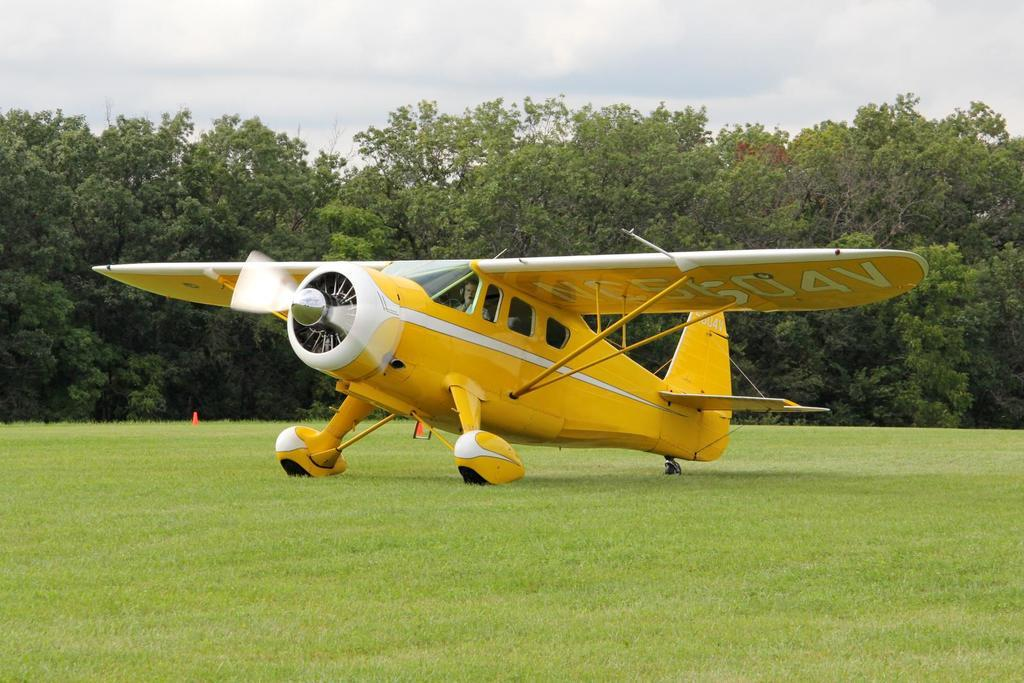What is the main subject of the image? The main subject of the image is a jet plane. What color is the jet plane? The jet plane is yellow. What type of vegetation is at the bottom of the image? There is green grass at the bottom of the image. What can be seen in the background of the image? There are trees in the background of the image. What is visible at the top of the image? The sky is visible at the top of the image. How does the jet plane help reduce pollution in the image? The image does not provide information about the jet plane's impact on pollution. What type of watch is the jet plane wearing in the image? There is no watch present in the image, as the subject is a jet plane, which is not capable of wearing a watch. 